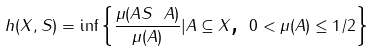Convert formula to latex. <formula><loc_0><loc_0><loc_500><loc_500>h ( X , S ) = \inf \left \{ \frac { \mu ( A S \ A ) } { \mu ( A ) } | A \subseteq X \text {, } 0 < \mu ( A ) \leq 1 / 2 \right \}</formula> 